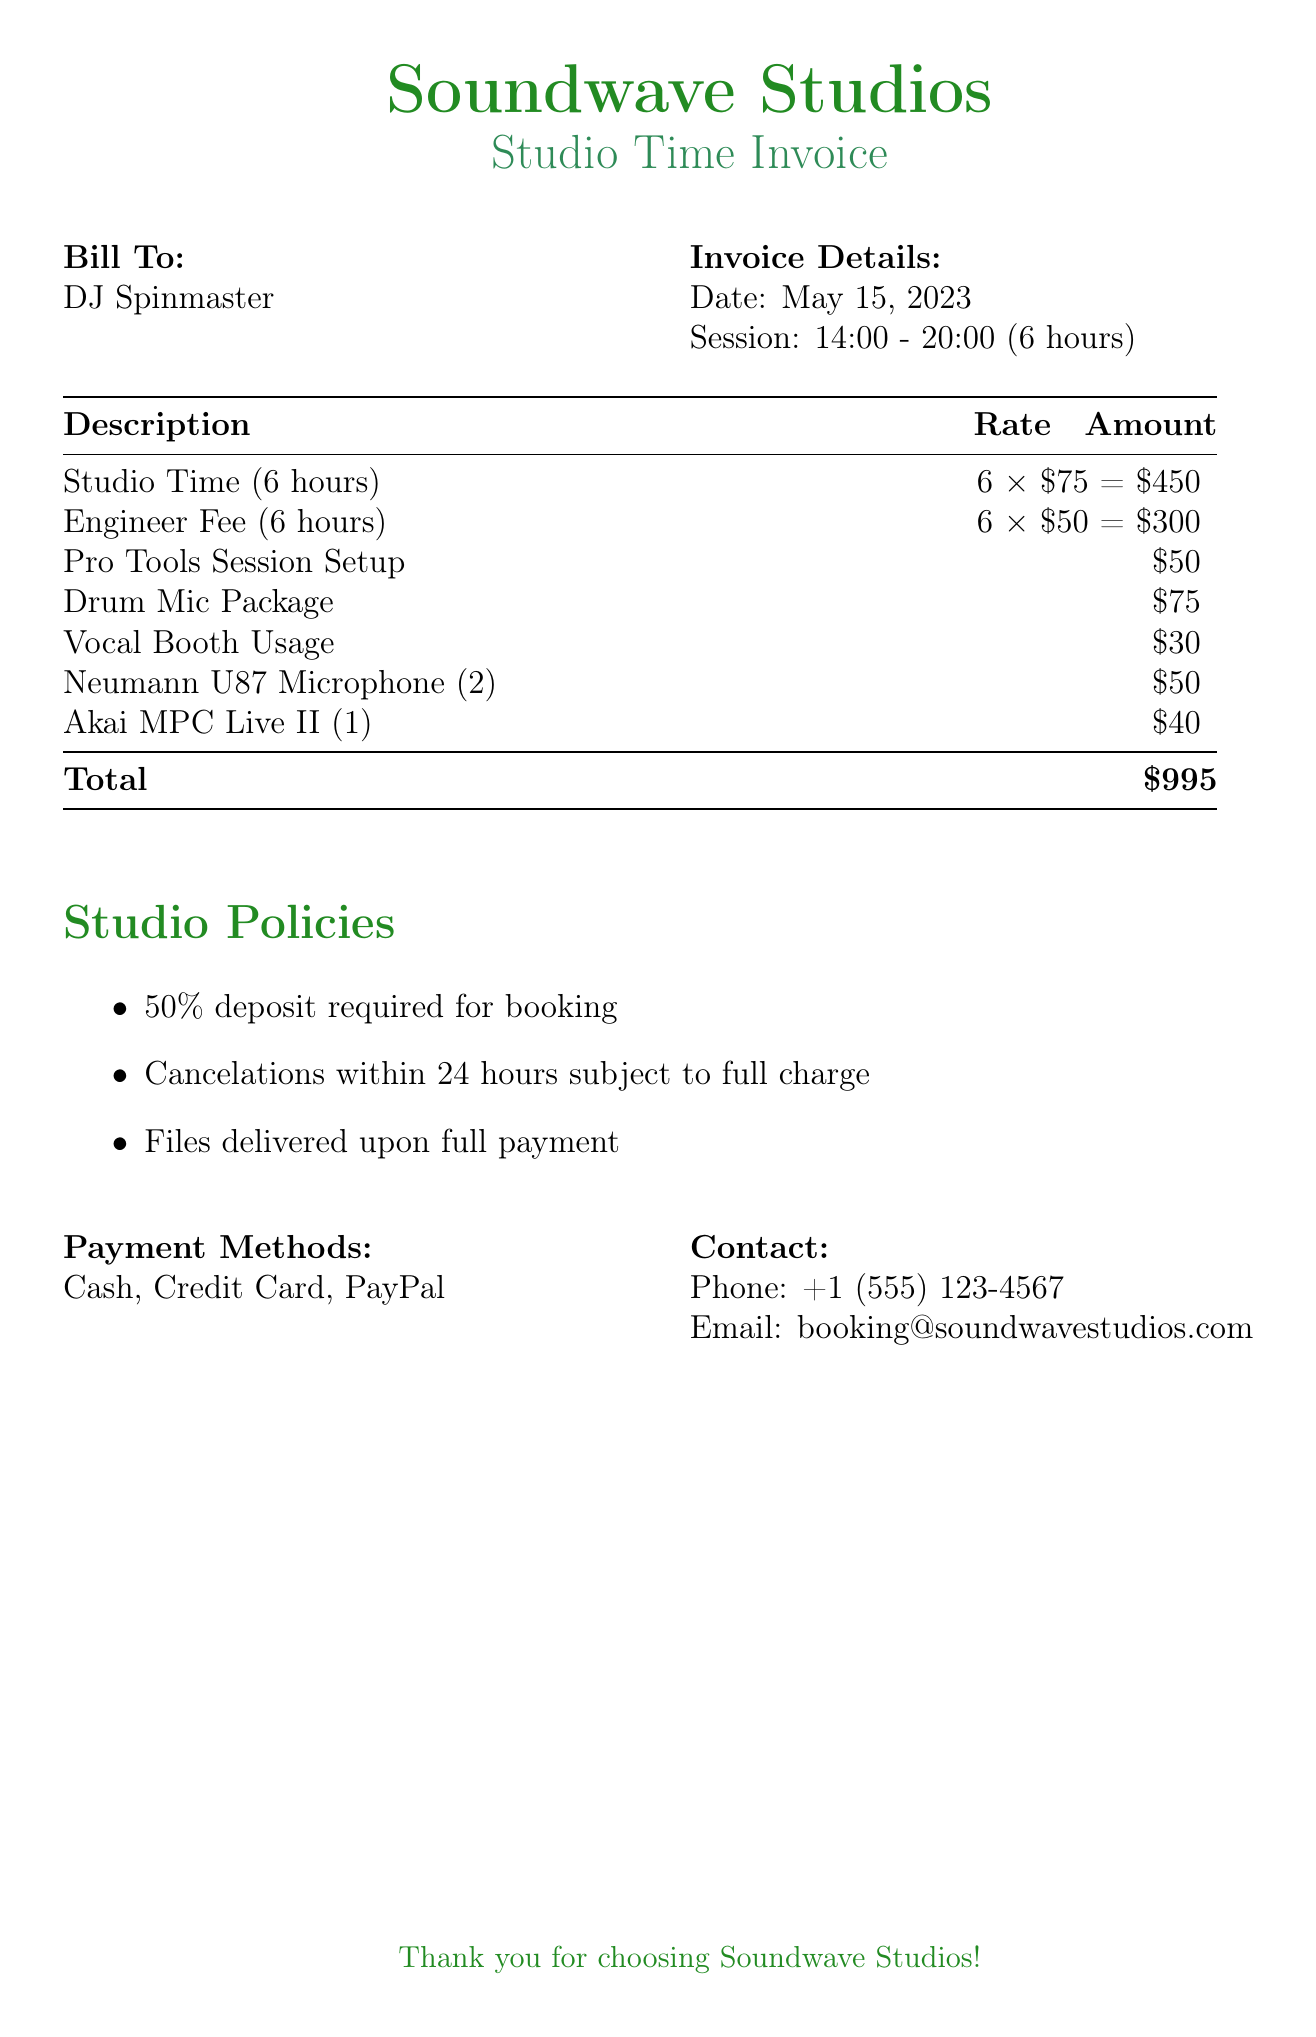What is the name of the studio? The document states the name of the studio as "Soundwave Studios."
Answer: Soundwave Studios Who is the bill addressed to? The bill is addressed to "DJ Spinmaster."
Answer: DJ Spinmaster What is the date of the invoice? The date mentioned in the document is "May 15, 2023."
Answer: May 15, 2023 How many hours of studio time were billed? The session duration specified in the document is "6 hours."
Answer: 6 hours What is the total amount due? The document shows the total amount due is "$995."
Answer: $995 What was the rate for the engineer fee? The rate listed for the engineer fee is "$50."
Answer: $50 How much was charged for the Pro Tools Session Setup? The charge for the Pro Tools Session Setup is "$50."
Answer: $50 What percentage is required for a deposit? The document states that a "50% deposit" is required for booking.
Answer: 50% What payment methods are accepted? The document lists "Cash, Credit Card, PayPal" as acceptable payment methods.
Answer: Cash, Credit Card, PayPal What is the phone number for contact? The contact phone number provided in the document is "+1 (555) 123-4567."
Answer: +1 (555) 123-4567 